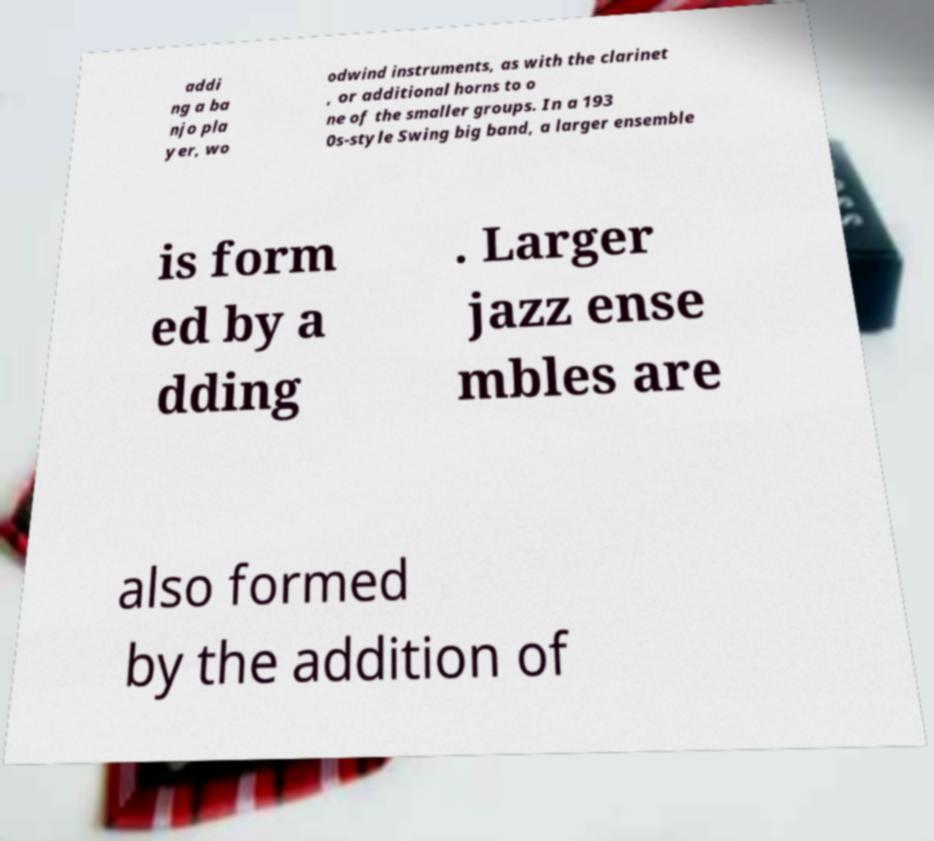Please identify and transcribe the text found in this image. addi ng a ba njo pla yer, wo odwind instruments, as with the clarinet , or additional horns to o ne of the smaller groups. In a 193 0s-style Swing big band, a larger ensemble is form ed by a dding . Larger jazz ense mbles are also formed by the addition of 